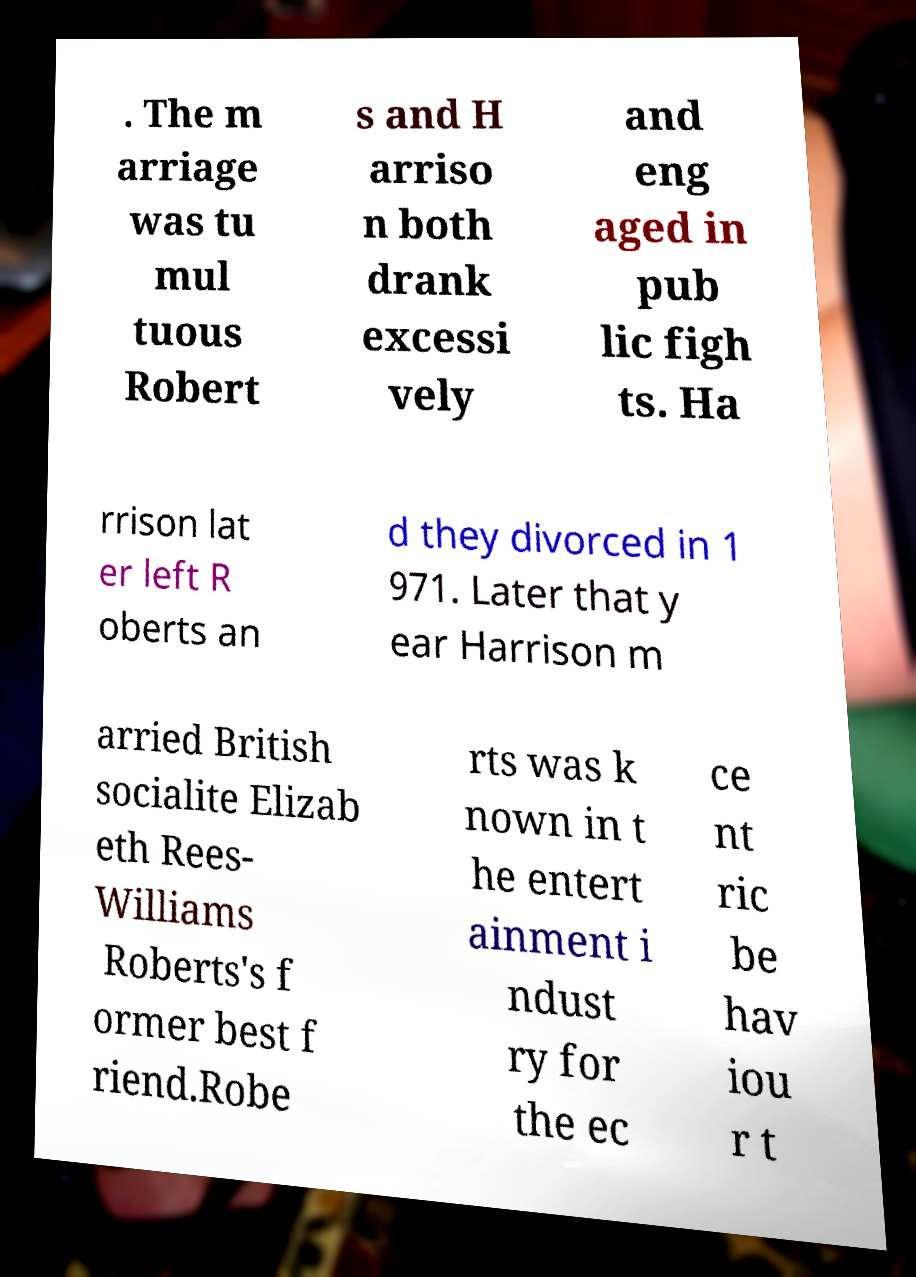Can you accurately transcribe the text from the provided image for me? . The m arriage was tu mul tuous Robert s and H arriso n both drank excessi vely and eng aged in pub lic figh ts. Ha rrison lat er left R oberts an d they divorced in 1 971. Later that y ear Harrison m arried British socialite Elizab eth Rees- Williams Roberts's f ormer best f riend.Robe rts was k nown in t he entert ainment i ndust ry for the ec ce nt ric be hav iou r t 